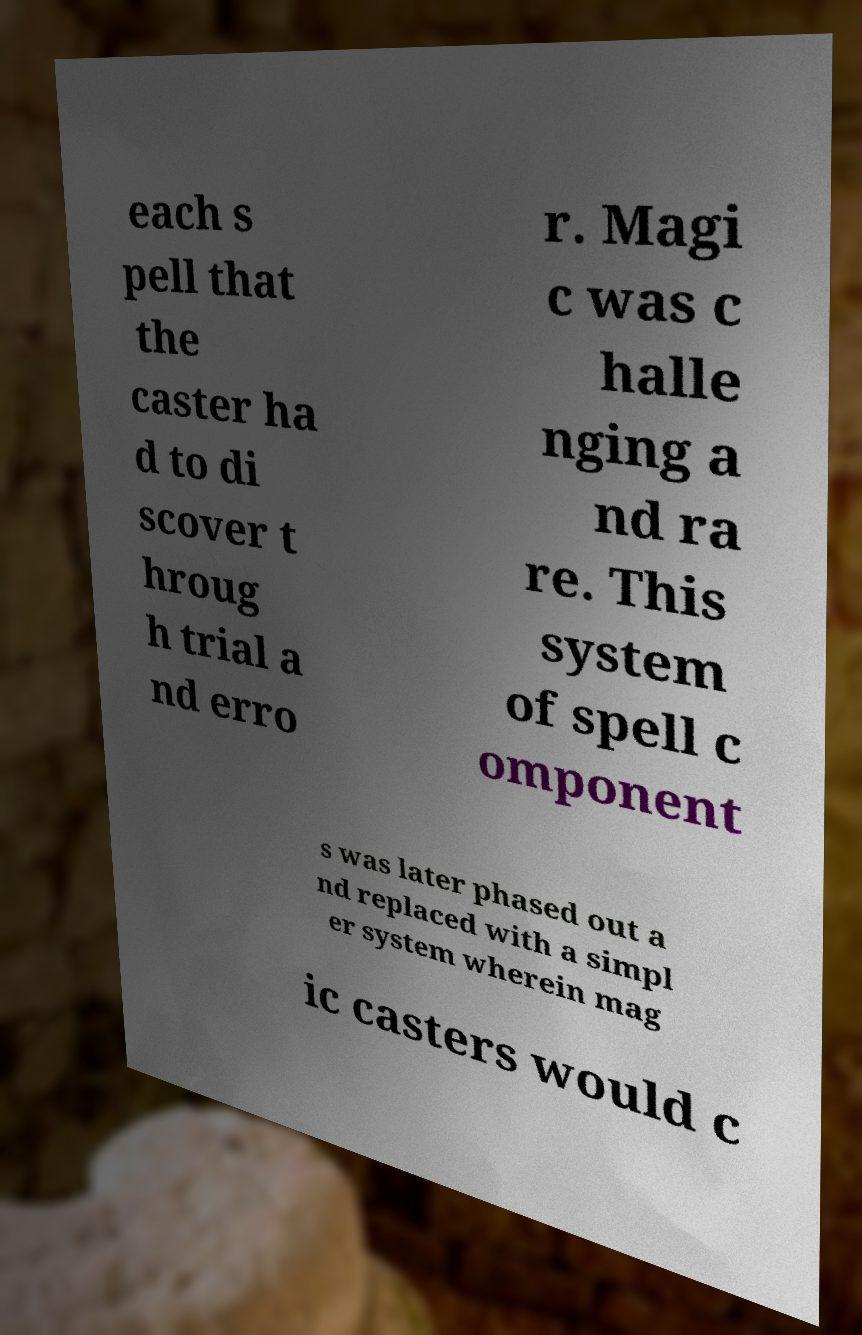Can you accurately transcribe the text from the provided image for me? each s pell that the caster ha d to di scover t hroug h trial a nd erro r. Magi c was c halle nging a nd ra re. This system of spell c omponent s was later phased out a nd replaced with a simpl er system wherein mag ic casters would c 